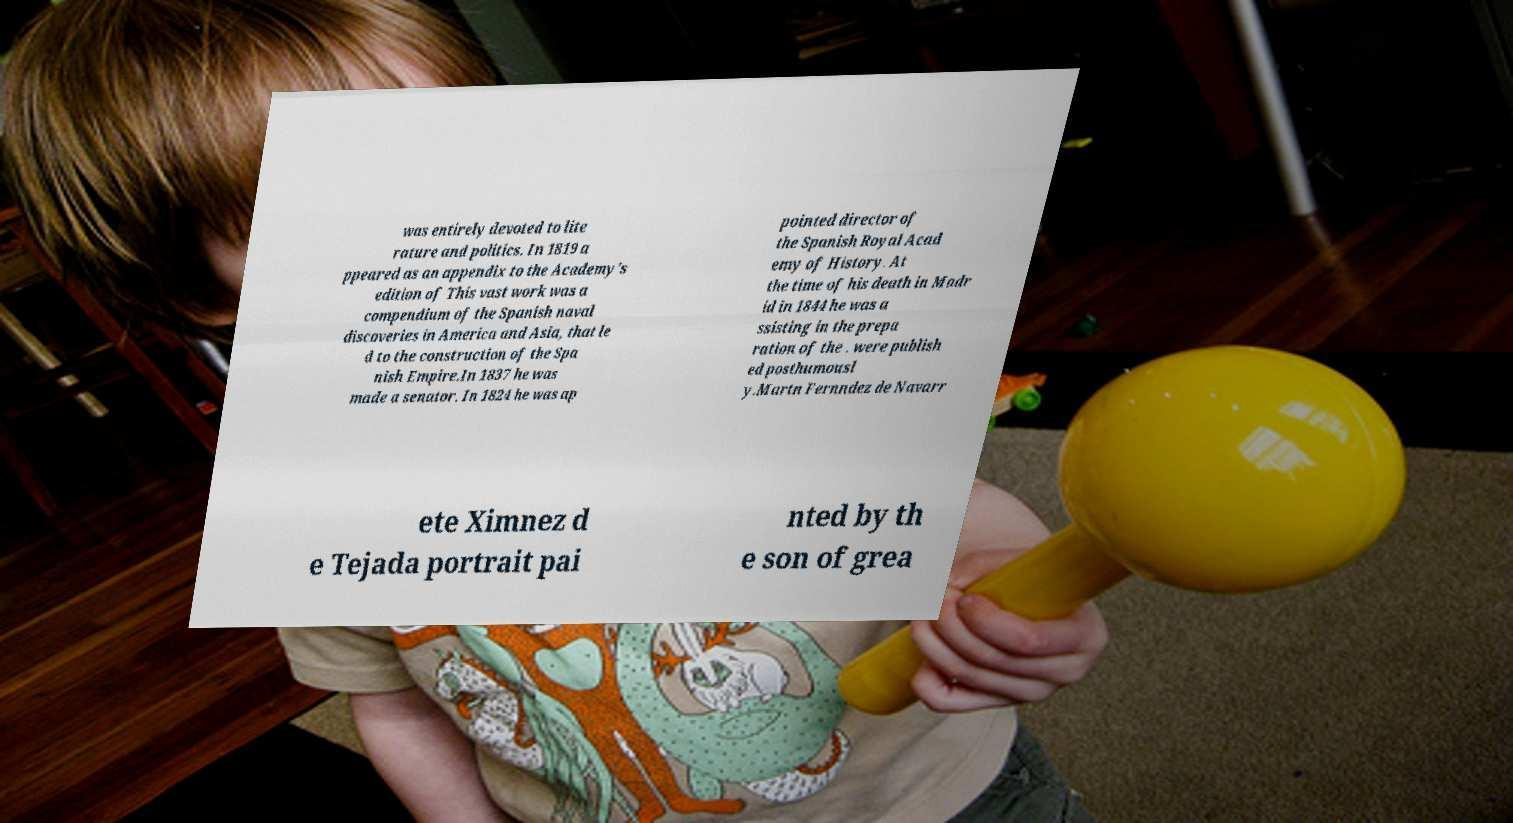There's text embedded in this image that I need extracted. Can you transcribe it verbatim? was entirely devoted to lite rature and politics. In 1819 a ppeared as an appendix to the Academy's edition of This vast work was a compendium of the Spanish naval discoveries in America and Asia, that le d to the construction of the Spa nish Empire.In 1837 he was made a senator. In 1824 he was ap pointed director of the Spanish Royal Acad emy of History. At the time of his death in Madr id in 1844 he was a ssisting in the prepa ration of the . were publish ed posthumousl y.Martn Fernndez de Navarr ete Ximnez d e Tejada portrait pai nted by th e son of grea 